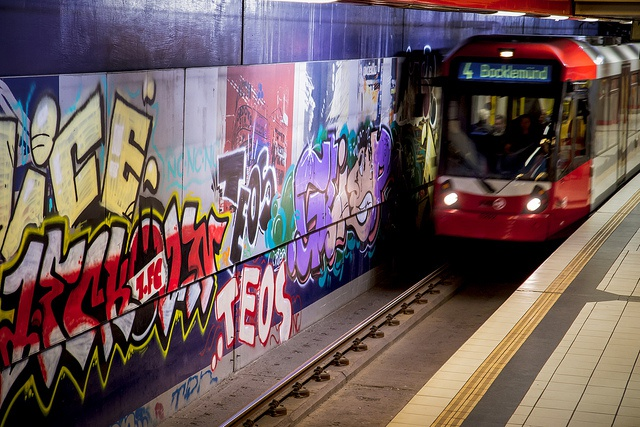Describe the objects in this image and their specific colors. I can see a train in black, maroon, gray, and olive tones in this image. 